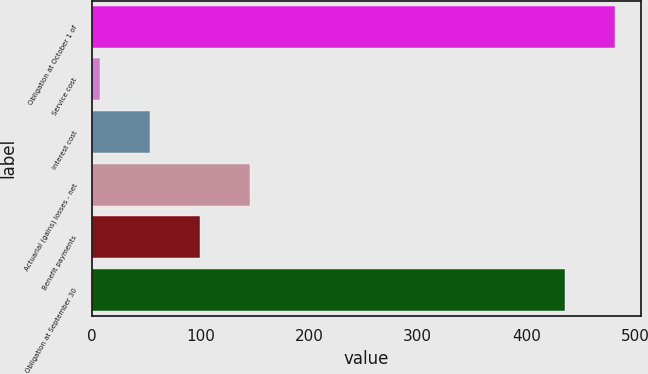Convert chart to OTSL. <chart><loc_0><loc_0><loc_500><loc_500><bar_chart><fcel>Obligation at October 1 of<fcel>Service cost<fcel>Interest cost<fcel>Actuarial (gains) losses - net<fcel>Benefit payments<fcel>Obligation at September 30<nl><fcel>481<fcel>8<fcel>54<fcel>146<fcel>100<fcel>435<nl></chart> 